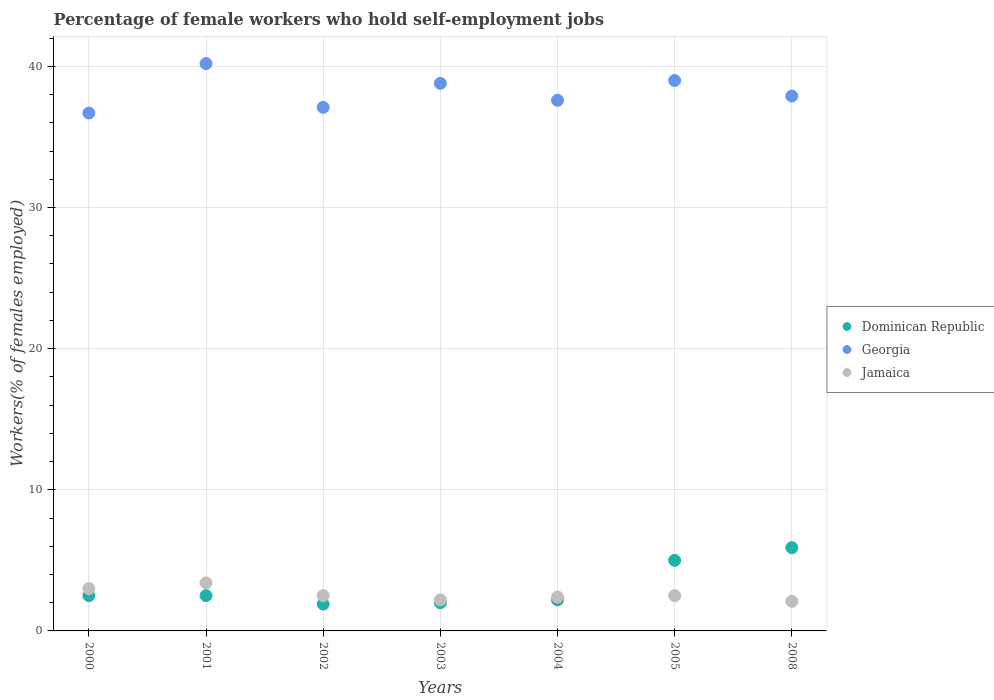How many different coloured dotlines are there?
Your answer should be very brief. 3. Is the number of dotlines equal to the number of legend labels?
Provide a succinct answer. Yes. What is the percentage of self-employed female workers in Georgia in 2003?
Make the answer very short. 38.8. Across all years, what is the maximum percentage of self-employed female workers in Dominican Republic?
Give a very brief answer. 5.9. Across all years, what is the minimum percentage of self-employed female workers in Georgia?
Ensure brevity in your answer.  36.7. In which year was the percentage of self-employed female workers in Dominican Republic maximum?
Offer a terse response. 2008. In which year was the percentage of self-employed female workers in Georgia minimum?
Ensure brevity in your answer.  2000. What is the total percentage of self-employed female workers in Georgia in the graph?
Keep it short and to the point. 267.3. What is the difference between the percentage of self-employed female workers in Georgia in 2000 and that in 2004?
Keep it short and to the point. -0.9. What is the difference between the percentage of self-employed female workers in Georgia in 2001 and the percentage of self-employed female workers in Jamaica in 2008?
Provide a short and direct response. 38.1. What is the average percentage of self-employed female workers in Jamaica per year?
Offer a terse response. 2.59. In the year 2001, what is the difference between the percentage of self-employed female workers in Dominican Republic and percentage of self-employed female workers in Georgia?
Provide a succinct answer. -37.7. What is the ratio of the percentage of self-employed female workers in Georgia in 2003 to that in 2004?
Your answer should be very brief. 1.03. Is the percentage of self-employed female workers in Georgia in 2001 less than that in 2004?
Provide a succinct answer. No. What is the difference between the highest and the second highest percentage of self-employed female workers in Georgia?
Provide a succinct answer. 1.2. What is the difference between the highest and the lowest percentage of self-employed female workers in Dominican Republic?
Your answer should be compact. 4. Does the percentage of self-employed female workers in Georgia monotonically increase over the years?
Ensure brevity in your answer.  No. Is the percentage of self-employed female workers in Dominican Republic strictly less than the percentage of self-employed female workers in Jamaica over the years?
Keep it short and to the point. No. What is the difference between two consecutive major ticks on the Y-axis?
Your answer should be very brief. 10. Are the values on the major ticks of Y-axis written in scientific E-notation?
Your response must be concise. No. Does the graph contain any zero values?
Your answer should be compact. No. Does the graph contain grids?
Provide a succinct answer. Yes. How are the legend labels stacked?
Your answer should be compact. Vertical. What is the title of the graph?
Give a very brief answer. Percentage of female workers who hold self-employment jobs. Does "Syrian Arab Republic" appear as one of the legend labels in the graph?
Your answer should be compact. No. What is the label or title of the Y-axis?
Provide a short and direct response. Workers(% of females employed). What is the Workers(% of females employed) of Georgia in 2000?
Provide a succinct answer. 36.7. What is the Workers(% of females employed) of Jamaica in 2000?
Offer a very short reply. 3. What is the Workers(% of females employed) in Georgia in 2001?
Make the answer very short. 40.2. What is the Workers(% of females employed) in Jamaica in 2001?
Your response must be concise. 3.4. What is the Workers(% of females employed) in Dominican Republic in 2002?
Provide a succinct answer. 1.9. What is the Workers(% of females employed) in Georgia in 2002?
Ensure brevity in your answer.  37.1. What is the Workers(% of females employed) of Jamaica in 2002?
Make the answer very short. 2.5. What is the Workers(% of females employed) of Georgia in 2003?
Make the answer very short. 38.8. What is the Workers(% of females employed) in Jamaica in 2003?
Your response must be concise. 2.2. What is the Workers(% of females employed) of Dominican Republic in 2004?
Your answer should be very brief. 2.2. What is the Workers(% of females employed) in Georgia in 2004?
Your response must be concise. 37.6. What is the Workers(% of females employed) in Jamaica in 2004?
Ensure brevity in your answer.  2.4. What is the Workers(% of females employed) in Dominican Republic in 2005?
Ensure brevity in your answer.  5. What is the Workers(% of females employed) of Dominican Republic in 2008?
Ensure brevity in your answer.  5.9. What is the Workers(% of females employed) in Georgia in 2008?
Your answer should be very brief. 37.9. What is the Workers(% of females employed) of Jamaica in 2008?
Your answer should be compact. 2.1. Across all years, what is the maximum Workers(% of females employed) of Dominican Republic?
Your response must be concise. 5.9. Across all years, what is the maximum Workers(% of females employed) in Georgia?
Your answer should be very brief. 40.2. Across all years, what is the maximum Workers(% of females employed) in Jamaica?
Ensure brevity in your answer.  3.4. Across all years, what is the minimum Workers(% of females employed) of Dominican Republic?
Offer a terse response. 1.9. Across all years, what is the minimum Workers(% of females employed) of Georgia?
Your response must be concise. 36.7. Across all years, what is the minimum Workers(% of females employed) of Jamaica?
Your response must be concise. 2.1. What is the total Workers(% of females employed) of Georgia in the graph?
Offer a very short reply. 267.3. What is the difference between the Workers(% of females employed) of Georgia in 2000 and that in 2001?
Your response must be concise. -3.5. What is the difference between the Workers(% of females employed) in Dominican Republic in 2000 and that in 2002?
Provide a short and direct response. 0.6. What is the difference between the Workers(% of females employed) in Georgia in 2000 and that in 2003?
Provide a short and direct response. -2.1. What is the difference between the Workers(% of females employed) in Dominican Republic in 2000 and that in 2004?
Your answer should be very brief. 0.3. What is the difference between the Workers(% of females employed) of Jamaica in 2000 and that in 2004?
Give a very brief answer. 0.6. What is the difference between the Workers(% of females employed) of Dominican Republic in 2000 and that in 2005?
Ensure brevity in your answer.  -2.5. What is the difference between the Workers(% of females employed) in Georgia in 2000 and that in 2008?
Offer a very short reply. -1.2. What is the difference between the Workers(% of females employed) of Jamaica in 2000 and that in 2008?
Offer a terse response. 0.9. What is the difference between the Workers(% of females employed) of Georgia in 2001 and that in 2002?
Provide a short and direct response. 3.1. What is the difference between the Workers(% of females employed) in Jamaica in 2001 and that in 2002?
Provide a short and direct response. 0.9. What is the difference between the Workers(% of females employed) in Dominican Republic in 2001 and that in 2003?
Provide a short and direct response. 0.5. What is the difference between the Workers(% of females employed) of Georgia in 2001 and that in 2004?
Your response must be concise. 2.6. What is the difference between the Workers(% of females employed) in Jamaica in 2001 and that in 2004?
Make the answer very short. 1. What is the difference between the Workers(% of females employed) of Georgia in 2001 and that in 2005?
Ensure brevity in your answer.  1.2. What is the difference between the Workers(% of females employed) of Jamaica in 2001 and that in 2005?
Make the answer very short. 0.9. What is the difference between the Workers(% of females employed) in Dominican Republic in 2001 and that in 2008?
Ensure brevity in your answer.  -3.4. What is the difference between the Workers(% of females employed) in Georgia in 2001 and that in 2008?
Give a very brief answer. 2.3. What is the difference between the Workers(% of females employed) of Georgia in 2002 and that in 2004?
Your answer should be compact. -0.5. What is the difference between the Workers(% of females employed) in Jamaica in 2002 and that in 2004?
Your answer should be compact. 0.1. What is the difference between the Workers(% of females employed) in Jamaica in 2002 and that in 2005?
Your response must be concise. 0. What is the difference between the Workers(% of females employed) in Jamaica in 2002 and that in 2008?
Provide a short and direct response. 0.4. What is the difference between the Workers(% of females employed) in Georgia in 2003 and that in 2004?
Make the answer very short. 1.2. What is the difference between the Workers(% of females employed) in Jamaica in 2003 and that in 2004?
Offer a very short reply. -0.2. What is the difference between the Workers(% of females employed) in Dominican Republic in 2003 and that in 2005?
Your answer should be very brief. -3. What is the difference between the Workers(% of females employed) of Dominican Republic in 2003 and that in 2008?
Make the answer very short. -3.9. What is the difference between the Workers(% of females employed) in Georgia in 2003 and that in 2008?
Your answer should be very brief. 0.9. What is the difference between the Workers(% of females employed) of Dominican Republic in 2004 and that in 2008?
Your answer should be compact. -3.7. What is the difference between the Workers(% of females employed) of Jamaica in 2004 and that in 2008?
Ensure brevity in your answer.  0.3. What is the difference between the Workers(% of females employed) in Dominican Republic in 2005 and that in 2008?
Your answer should be very brief. -0.9. What is the difference between the Workers(% of females employed) of Jamaica in 2005 and that in 2008?
Make the answer very short. 0.4. What is the difference between the Workers(% of females employed) in Dominican Republic in 2000 and the Workers(% of females employed) in Georgia in 2001?
Ensure brevity in your answer.  -37.7. What is the difference between the Workers(% of females employed) in Dominican Republic in 2000 and the Workers(% of females employed) in Jamaica in 2001?
Ensure brevity in your answer.  -0.9. What is the difference between the Workers(% of females employed) of Georgia in 2000 and the Workers(% of females employed) of Jamaica in 2001?
Give a very brief answer. 33.3. What is the difference between the Workers(% of females employed) of Dominican Republic in 2000 and the Workers(% of females employed) of Georgia in 2002?
Your answer should be compact. -34.6. What is the difference between the Workers(% of females employed) of Georgia in 2000 and the Workers(% of females employed) of Jamaica in 2002?
Ensure brevity in your answer.  34.2. What is the difference between the Workers(% of females employed) in Dominican Republic in 2000 and the Workers(% of females employed) in Georgia in 2003?
Offer a very short reply. -36.3. What is the difference between the Workers(% of females employed) of Georgia in 2000 and the Workers(% of females employed) of Jamaica in 2003?
Give a very brief answer. 34.5. What is the difference between the Workers(% of females employed) of Dominican Republic in 2000 and the Workers(% of females employed) of Georgia in 2004?
Keep it short and to the point. -35.1. What is the difference between the Workers(% of females employed) of Dominican Republic in 2000 and the Workers(% of females employed) of Jamaica in 2004?
Make the answer very short. 0.1. What is the difference between the Workers(% of females employed) in Georgia in 2000 and the Workers(% of females employed) in Jamaica in 2004?
Ensure brevity in your answer.  34.3. What is the difference between the Workers(% of females employed) in Dominican Republic in 2000 and the Workers(% of females employed) in Georgia in 2005?
Your answer should be very brief. -36.5. What is the difference between the Workers(% of females employed) in Dominican Republic in 2000 and the Workers(% of females employed) in Jamaica in 2005?
Offer a terse response. 0. What is the difference between the Workers(% of females employed) in Georgia in 2000 and the Workers(% of females employed) in Jamaica in 2005?
Provide a short and direct response. 34.2. What is the difference between the Workers(% of females employed) of Dominican Republic in 2000 and the Workers(% of females employed) of Georgia in 2008?
Give a very brief answer. -35.4. What is the difference between the Workers(% of females employed) in Georgia in 2000 and the Workers(% of females employed) in Jamaica in 2008?
Ensure brevity in your answer.  34.6. What is the difference between the Workers(% of females employed) in Dominican Republic in 2001 and the Workers(% of females employed) in Georgia in 2002?
Offer a very short reply. -34.6. What is the difference between the Workers(% of females employed) in Dominican Republic in 2001 and the Workers(% of females employed) in Jamaica in 2002?
Ensure brevity in your answer.  0. What is the difference between the Workers(% of females employed) of Georgia in 2001 and the Workers(% of females employed) of Jamaica in 2002?
Provide a short and direct response. 37.7. What is the difference between the Workers(% of females employed) in Dominican Republic in 2001 and the Workers(% of females employed) in Georgia in 2003?
Provide a succinct answer. -36.3. What is the difference between the Workers(% of females employed) of Dominican Republic in 2001 and the Workers(% of females employed) of Georgia in 2004?
Your answer should be very brief. -35.1. What is the difference between the Workers(% of females employed) of Dominican Republic in 2001 and the Workers(% of females employed) of Jamaica in 2004?
Give a very brief answer. 0.1. What is the difference between the Workers(% of females employed) in Georgia in 2001 and the Workers(% of females employed) in Jamaica in 2004?
Make the answer very short. 37.8. What is the difference between the Workers(% of females employed) of Dominican Republic in 2001 and the Workers(% of females employed) of Georgia in 2005?
Your answer should be compact. -36.5. What is the difference between the Workers(% of females employed) of Dominican Republic in 2001 and the Workers(% of females employed) of Jamaica in 2005?
Your answer should be compact. 0. What is the difference between the Workers(% of females employed) in Georgia in 2001 and the Workers(% of females employed) in Jamaica in 2005?
Your response must be concise. 37.7. What is the difference between the Workers(% of females employed) of Dominican Republic in 2001 and the Workers(% of females employed) of Georgia in 2008?
Offer a terse response. -35.4. What is the difference between the Workers(% of females employed) in Georgia in 2001 and the Workers(% of females employed) in Jamaica in 2008?
Give a very brief answer. 38.1. What is the difference between the Workers(% of females employed) in Dominican Republic in 2002 and the Workers(% of females employed) in Georgia in 2003?
Provide a short and direct response. -36.9. What is the difference between the Workers(% of females employed) of Dominican Republic in 2002 and the Workers(% of females employed) of Jamaica in 2003?
Your answer should be very brief. -0.3. What is the difference between the Workers(% of females employed) in Georgia in 2002 and the Workers(% of females employed) in Jamaica in 2003?
Keep it short and to the point. 34.9. What is the difference between the Workers(% of females employed) in Dominican Republic in 2002 and the Workers(% of females employed) in Georgia in 2004?
Offer a very short reply. -35.7. What is the difference between the Workers(% of females employed) in Dominican Republic in 2002 and the Workers(% of females employed) in Jamaica in 2004?
Keep it short and to the point. -0.5. What is the difference between the Workers(% of females employed) of Georgia in 2002 and the Workers(% of females employed) of Jamaica in 2004?
Your answer should be very brief. 34.7. What is the difference between the Workers(% of females employed) in Dominican Republic in 2002 and the Workers(% of females employed) in Georgia in 2005?
Your answer should be very brief. -37.1. What is the difference between the Workers(% of females employed) of Georgia in 2002 and the Workers(% of females employed) of Jamaica in 2005?
Your answer should be very brief. 34.6. What is the difference between the Workers(% of females employed) in Dominican Republic in 2002 and the Workers(% of females employed) in Georgia in 2008?
Provide a succinct answer. -36. What is the difference between the Workers(% of females employed) in Dominican Republic in 2002 and the Workers(% of females employed) in Jamaica in 2008?
Ensure brevity in your answer.  -0.2. What is the difference between the Workers(% of females employed) of Georgia in 2002 and the Workers(% of females employed) of Jamaica in 2008?
Your answer should be compact. 35. What is the difference between the Workers(% of females employed) in Dominican Republic in 2003 and the Workers(% of females employed) in Georgia in 2004?
Offer a terse response. -35.6. What is the difference between the Workers(% of females employed) in Georgia in 2003 and the Workers(% of females employed) in Jamaica in 2004?
Your response must be concise. 36.4. What is the difference between the Workers(% of females employed) of Dominican Republic in 2003 and the Workers(% of females employed) of Georgia in 2005?
Provide a succinct answer. -37. What is the difference between the Workers(% of females employed) of Dominican Republic in 2003 and the Workers(% of females employed) of Jamaica in 2005?
Offer a very short reply. -0.5. What is the difference between the Workers(% of females employed) of Georgia in 2003 and the Workers(% of females employed) of Jamaica in 2005?
Ensure brevity in your answer.  36.3. What is the difference between the Workers(% of females employed) in Dominican Republic in 2003 and the Workers(% of females employed) in Georgia in 2008?
Provide a succinct answer. -35.9. What is the difference between the Workers(% of females employed) in Georgia in 2003 and the Workers(% of females employed) in Jamaica in 2008?
Offer a very short reply. 36.7. What is the difference between the Workers(% of females employed) in Dominican Republic in 2004 and the Workers(% of females employed) in Georgia in 2005?
Ensure brevity in your answer.  -36.8. What is the difference between the Workers(% of females employed) in Georgia in 2004 and the Workers(% of females employed) in Jamaica in 2005?
Offer a very short reply. 35.1. What is the difference between the Workers(% of females employed) of Dominican Republic in 2004 and the Workers(% of females employed) of Georgia in 2008?
Make the answer very short. -35.7. What is the difference between the Workers(% of females employed) of Dominican Republic in 2004 and the Workers(% of females employed) of Jamaica in 2008?
Offer a terse response. 0.1. What is the difference between the Workers(% of females employed) of Georgia in 2004 and the Workers(% of females employed) of Jamaica in 2008?
Provide a succinct answer. 35.5. What is the difference between the Workers(% of females employed) of Dominican Republic in 2005 and the Workers(% of females employed) of Georgia in 2008?
Your answer should be compact. -32.9. What is the difference between the Workers(% of females employed) in Georgia in 2005 and the Workers(% of females employed) in Jamaica in 2008?
Provide a succinct answer. 36.9. What is the average Workers(% of females employed) in Dominican Republic per year?
Offer a terse response. 3.14. What is the average Workers(% of females employed) of Georgia per year?
Your response must be concise. 38.19. What is the average Workers(% of females employed) of Jamaica per year?
Your answer should be very brief. 2.59. In the year 2000, what is the difference between the Workers(% of females employed) in Dominican Republic and Workers(% of females employed) in Georgia?
Provide a succinct answer. -34.2. In the year 2000, what is the difference between the Workers(% of females employed) in Dominican Republic and Workers(% of females employed) in Jamaica?
Keep it short and to the point. -0.5. In the year 2000, what is the difference between the Workers(% of females employed) of Georgia and Workers(% of females employed) of Jamaica?
Offer a very short reply. 33.7. In the year 2001, what is the difference between the Workers(% of females employed) of Dominican Republic and Workers(% of females employed) of Georgia?
Your response must be concise. -37.7. In the year 2001, what is the difference between the Workers(% of females employed) in Dominican Republic and Workers(% of females employed) in Jamaica?
Your answer should be very brief. -0.9. In the year 2001, what is the difference between the Workers(% of females employed) of Georgia and Workers(% of females employed) of Jamaica?
Give a very brief answer. 36.8. In the year 2002, what is the difference between the Workers(% of females employed) in Dominican Republic and Workers(% of females employed) in Georgia?
Provide a succinct answer. -35.2. In the year 2002, what is the difference between the Workers(% of females employed) of Dominican Republic and Workers(% of females employed) of Jamaica?
Give a very brief answer. -0.6. In the year 2002, what is the difference between the Workers(% of females employed) in Georgia and Workers(% of females employed) in Jamaica?
Provide a succinct answer. 34.6. In the year 2003, what is the difference between the Workers(% of females employed) in Dominican Republic and Workers(% of females employed) in Georgia?
Your response must be concise. -36.8. In the year 2003, what is the difference between the Workers(% of females employed) of Dominican Republic and Workers(% of females employed) of Jamaica?
Your answer should be compact. -0.2. In the year 2003, what is the difference between the Workers(% of females employed) in Georgia and Workers(% of females employed) in Jamaica?
Keep it short and to the point. 36.6. In the year 2004, what is the difference between the Workers(% of females employed) in Dominican Republic and Workers(% of females employed) in Georgia?
Your response must be concise. -35.4. In the year 2004, what is the difference between the Workers(% of females employed) of Dominican Republic and Workers(% of females employed) of Jamaica?
Make the answer very short. -0.2. In the year 2004, what is the difference between the Workers(% of females employed) in Georgia and Workers(% of females employed) in Jamaica?
Your answer should be compact. 35.2. In the year 2005, what is the difference between the Workers(% of females employed) in Dominican Republic and Workers(% of females employed) in Georgia?
Keep it short and to the point. -34. In the year 2005, what is the difference between the Workers(% of females employed) in Dominican Republic and Workers(% of females employed) in Jamaica?
Offer a very short reply. 2.5. In the year 2005, what is the difference between the Workers(% of females employed) in Georgia and Workers(% of females employed) in Jamaica?
Ensure brevity in your answer.  36.5. In the year 2008, what is the difference between the Workers(% of females employed) of Dominican Republic and Workers(% of females employed) of Georgia?
Make the answer very short. -32. In the year 2008, what is the difference between the Workers(% of females employed) of Georgia and Workers(% of females employed) of Jamaica?
Offer a terse response. 35.8. What is the ratio of the Workers(% of females employed) of Georgia in 2000 to that in 2001?
Your answer should be very brief. 0.91. What is the ratio of the Workers(% of females employed) in Jamaica in 2000 to that in 2001?
Keep it short and to the point. 0.88. What is the ratio of the Workers(% of females employed) of Dominican Republic in 2000 to that in 2002?
Your answer should be compact. 1.32. What is the ratio of the Workers(% of females employed) in Georgia in 2000 to that in 2002?
Keep it short and to the point. 0.99. What is the ratio of the Workers(% of females employed) in Georgia in 2000 to that in 2003?
Your response must be concise. 0.95. What is the ratio of the Workers(% of females employed) in Jamaica in 2000 to that in 2003?
Give a very brief answer. 1.36. What is the ratio of the Workers(% of females employed) in Dominican Republic in 2000 to that in 2004?
Provide a succinct answer. 1.14. What is the ratio of the Workers(% of females employed) in Georgia in 2000 to that in 2004?
Your answer should be very brief. 0.98. What is the ratio of the Workers(% of females employed) in Jamaica in 2000 to that in 2004?
Your answer should be compact. 1.25. What is the ratio of the Workers(% of females employed) in Georgia in 2000 to that in 2005?
Give a very brief answer. 0.94. What is the ratio of the Workers(% of females employed) of Jamaica in 2000 to that in 2005?
Make the answer very short. 1.2. What is the ratio of the Workers(% of females employed) in Dominican Republic in 2000 to that in 2008?
Keep it short and to the point. 0.42. What is the ratio of the Workers(% of females employed) in Georgia in 2000 to that in 2008?
Ensure brevity in your answer.  0.97. What is the ratio of the Workers(% of females employed) in Jamaica in 2000 to that in 2008?
Offer a terse response. 1.43. What is the ratio of the Workers(% of females employed) in Dominican Republic in 2001 to that in 2002?
Provide a succinct answer. 1.32. What is the ratio of the Workers(% of females employed) of Georgia in 2001 to that in 2002?
Offer a very short reply. 1.08. What is the ratio of the Workers(% of females employed) in Jamaica in 2001 to that in 2002?
Offer a terse response. 1.36. What is the ratio of the Workers(% of females employed) of Georgia in 2001 to that in 2003?
Keep it short and to the point. 1.04. What is the ratio of the Workers(% of females employed) in Jamaica in 2001 to that in 2003?
Keep it short and to the point. 1.55. What is the ratio of the Workers(% of females employed) in Dominican Republic in 2001 to that in 2004?
Offer a terse response. 1.14. What is the ratio of the Workers(% of females employed) of Georgia in 2001 to that in 2004?
Keep it short and to the point. 1.07. What is the ratio of the Workers(% of females employed) in Jamaica in 2001 to that in 2004?
Make the answer very short. 1.42. What is the ratio of the Workers(% of females employed) of Georgia in 2001 to that in 2005?
Your response must be concise. 1.03. What is the ratio of the Workers(% of females employed) in Jamaica in 2001 to that in 2005?
Offer a terse response. 1.36. What is the ratio of the Workers(% of females employed) in Dominican Republic in 2001 to that in 2008?
Your response must be concise. 0.42. What is the ratio of the Workers(% of females employed) in Georgia in 2001 to that in 2008?
Your answer should be compact. 1.06. What is the ratio of the Workers(% of females employed) of Jamaica in 2001 to that in 2008?
Your response must be concise. 1.62. What is the ratio of the Workers(% of females employed) in Georgia in 2002 to that in 2003?
Offer a terse response. 0.96. What is the ratio of the Workers(% of females employed) of Jamaica in 2002 to that in 2003?
Ensure brevity in your answer.  1.14. What is the ratio of the Workers(% of females employed) in Dominican Republic in 2002 to that in 2004?
Your answer should be compact. 0.86. What is the ratio of the Workers(% of females employed) of Georgia in 2002 to that in 2004?
Offer a very short reply. 0.99. What is the ratio of the Workers(% of females employed) of Jamaica in 2002 to that in 2004?
Ensure brevity in your answer.  1.04. What is the ratio of the Workers(% of females employed) in Dominican Republic in 2002 to that in 2005?
Offer a terse response. 0.38. What is the ratio of the Workers(% of females employed) of Georgia in 2002 to that in 2005?
Your response must be concise. 0.95. What is the ratio of the Workers(% of females employed) in Dominican Republic in 2002 to that in 2008?
Ensure brevity in your answer.  0.32. What is the ratio of the Workers(% of females employed) of Georgia in 2002 to that in 2008?
Your answer should be very brief. 0.98. What is the ratio of the Workers(% of females employed) in Jamaica in 2002 to that in 2008?
Keep it short and to the point. 1.19. What is the ratio of the Workers(% of females employed) of Dominican Republic in 2003 to that in 2004?
Ensure brevity in your answer.  0.91. What is the ratio of the Workers(% of females employed) of Georgia in 2003 to that in 2004?
Keep it short and to the point. 1.03. What is the ratio of the Workers(% of females employed) of Dominican Republic in 2003 to that in 2005?
Make the answer very short. 0.4. What is the ratio of the Workers(% of females employed) in Jamaica in 2003 to that in 2005?
Your answer should be very brief. 0.88. What is the ratio of the Workers(% of females employed) in Dominican Republic in 2003 to that in 2008?
Provide a short and direct response. 0.34. What is the ratio of the Workers(% of females employed) in Georgia in 2003 to that in 2008?
Provide a short and direct response. 1.02. What is the ratio of the Workers(% of females employed) of Jamaica in 2003 to that in 2008?
Your answer should be compact. 1.05. What is the ratio of the Workers(% of females employed) in Dominican Republic in 2004 to that in 2005?
Make the answer very short. 0.44. What is the ratio of the Workers(% of females employed) in Georgia in 2004 to that in 2005?
Provide a short and direct response. 0.96. What is the ratio of the Workers(% of females employed) in Dominican Republic in 2004 to that in 2008?
Offer a very short reply. 0.37. What is the ratio of the Workers(% of females employed) in Dominican Republic in 2005 to that in 2008?
Provide a short and direct response. 0.85. What is the ratio of the Workers(% of females employed) in Georgia in 2005 to that in 2008?
Make the answer very short. 1.03. What is the ratio of the Workers(% of females employed) of Jamaica in 2005 to that in 2008?
Provide a short and direct response. 1.19. What is the difference between the highest and the second highest Workers(% of females employed) of Georgia?
Give a very brief answer. 1.2. What is the difference between the highest and the second highest Workers(% of females employed) of Jamaica?
Provide a succinct answer. 0.4. What is the difference between the highest and the lowest Workers(% of females employed) of Georgia?
Make the answer very short. 3.5. 